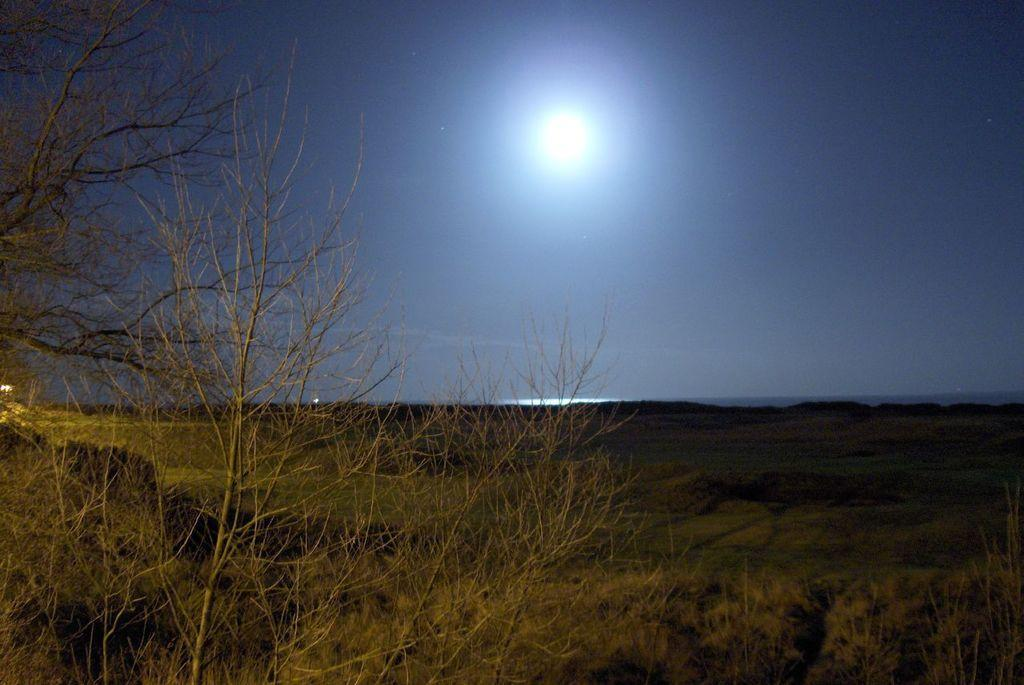What type of surface can be seen in the image? There is ground visible in the image. What kind of vegetation is present on the ground? There is grass on the ground. Are there any plants that appear to be dried or dead in the image? Yes, there are dried plants in the image. What can be seen in the sky in the image? The sky is visible in the image, and the moon is present. What type of quartz can be seen in the image? There is no quartz present in the image. Is there a pie visible in the image? There is no pie present in the image. 